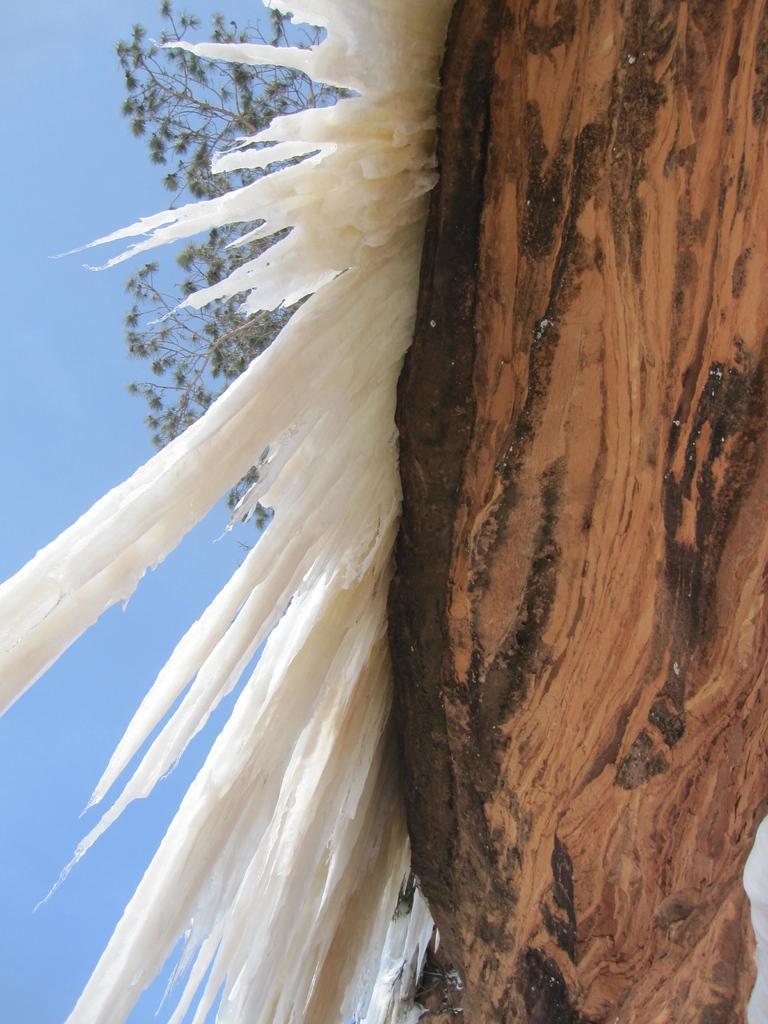How would you summarize this image in a sentence or two? In this image in the front there is a tree and there is an object which is white in colour. In the background there are leaves. 